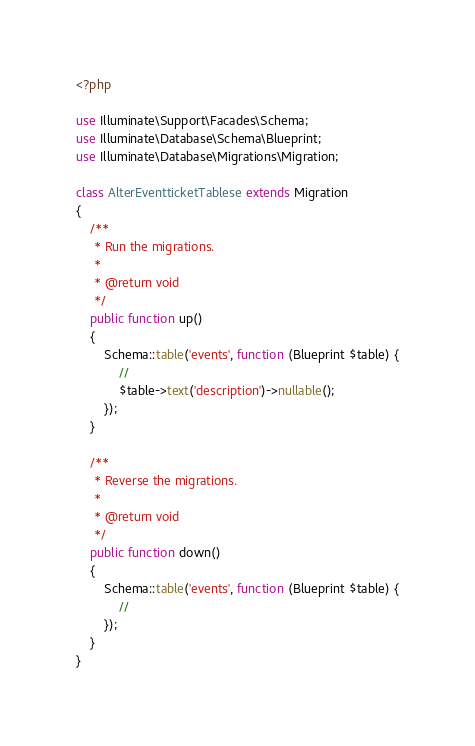Convert code to text. <code><loc_0><loc_0><loc_500><loc_500><_PHP_><?php

use Illuminate\Support\Facades\Schema;
use Illuminate\Database\Schema\Blueprint;
use Illuminate\Database\Migrations\Migration;

class AlterEventticketTablese extends Migration
{
    /**
     * Run the migrations.
     *
     * @return void
     */
    public function up()
    {
        Schema::table('events', function (Blueprint $table) {
            //
            $table->text('description')->nullable();
        });
    }

    /**
     * Reverse the migrations.
     *
     * @return void
     */
    public function down()
    {
        Schema::table('events', function (Blueprint $table) {
            //
        });
    }
}
</code> 